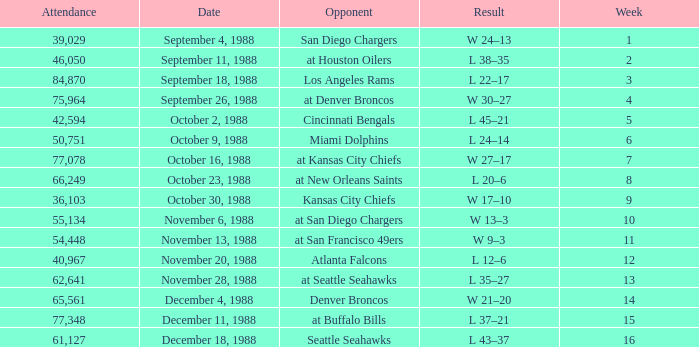What was the date during week 13? November 28, 1988. 